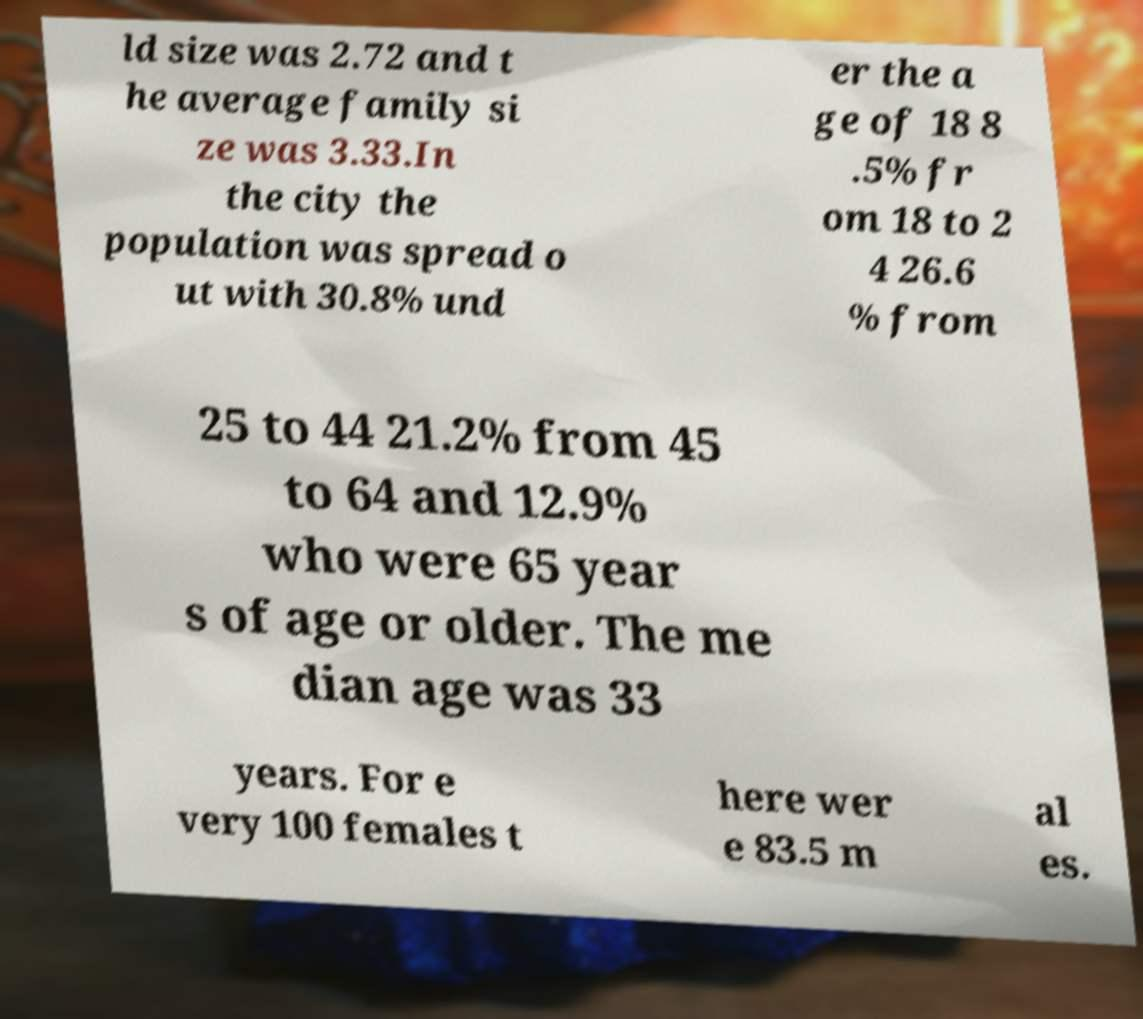There's text embedded in this image that I need extracted. Can you transcribe it verbatim? ld size was 2.72 and t he average family si ze was 3.33.In the city the population was spread o ut with 30.8% und er the a ge of 18 8 .5% fr om 18 to 2 4 26.6 % from 25 to 44 21.2% from 45 to 64 and 12.9% who were 65 year s of age or older. The me dian age was 33 years. For e very 100 females t here wer e 83.5 m al es. 